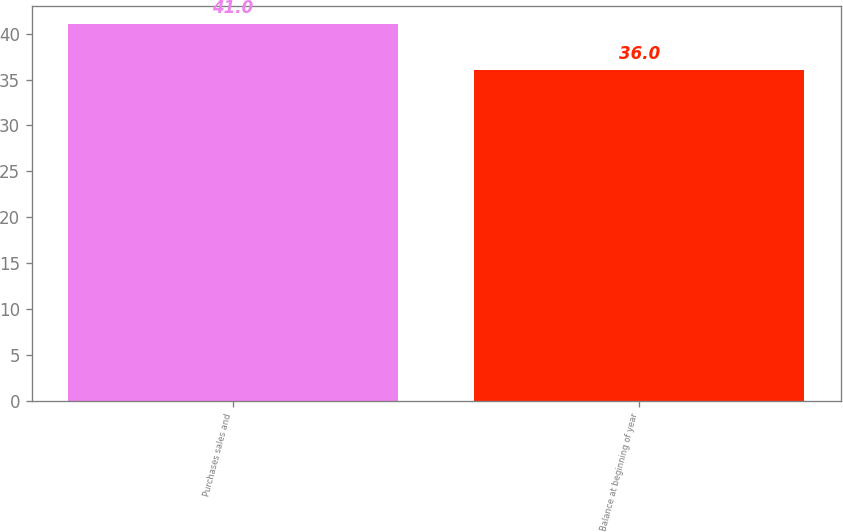<chart> <loc_0><loc_0><loc_500><loc_500><bar_chart><fcel>Purchases sales and<fcel>Balance at beginning of year<nl><fcel>41<fcel>36<nl></chart> 